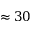<formula> <loc_0><loc_0><loc_500><loc_500>\approx 3 0</formula> 